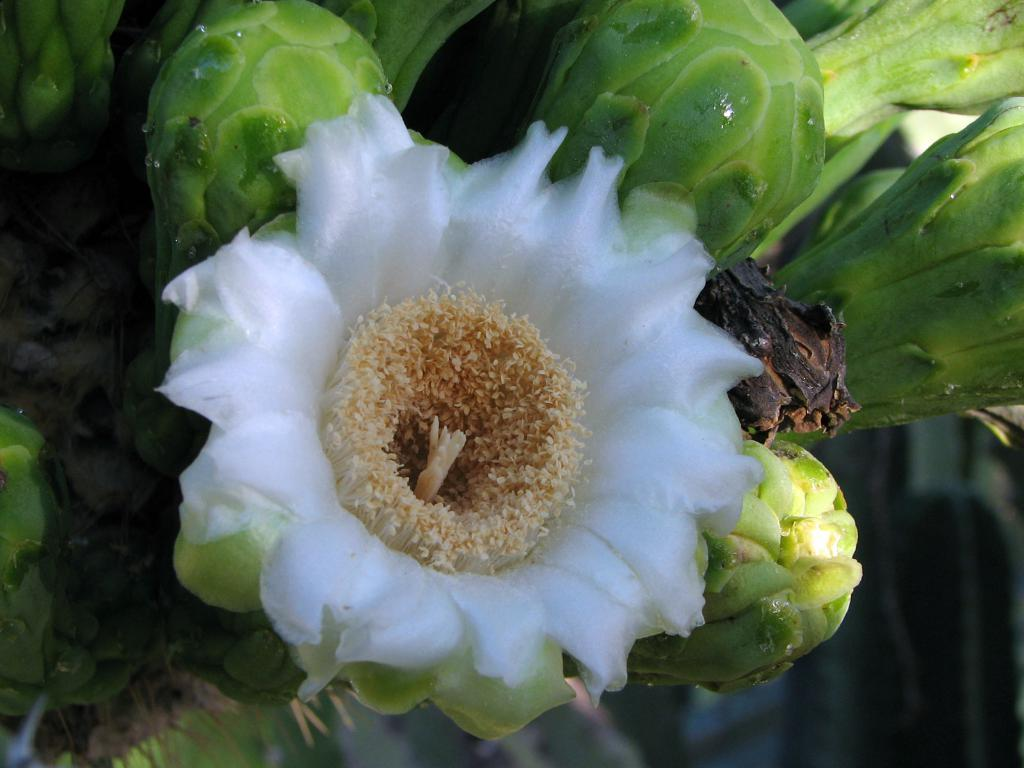What type of living organisms can be seen in the image? Plants can be seen in the image. Are there any specific features on any of the plants? Yes, there is a flower on one of the plants. Can you see any oranges growing on the plants in the image? There are no oranges present in the image; it features plants with a flower. Is there a lake visible in the background of the image? There is no lake present in the image; it only features plants and a flower. 